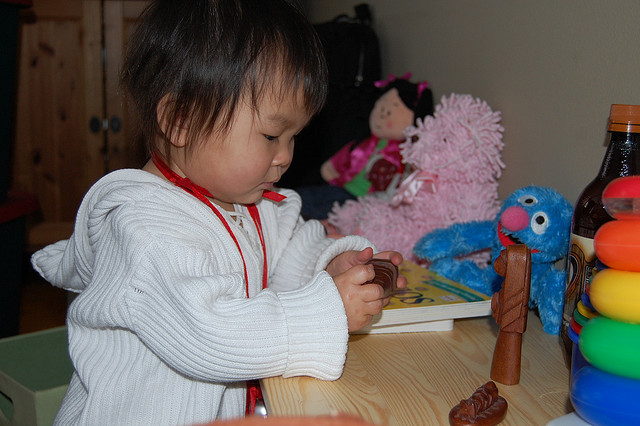<image>Why are there handles on these toys? It is ambiguous why there are handles on these toys. It could be for the baby to hold or for safety. What are the names of the stuffed animals in the high chair? I don't know the names of the stuffed animals in the high chair. They could be Elmo, Cookie Monster, Bob James, Kate, or Grover. What song was being sung while this picture was taken? It's impossible to know what song was being sung while this picture was taken. Why are there handles on these toys? There are handles on these toys for easy gripping and holding. What are the names of the stuffed animals in the high chair? I don't know the names of the stuffed animals in the high chair. What song was being sung while this picture was taken? I don't know what song was being sung while this picture was taken. It can be 'happy birthday', 'b c's', 'if your happy', 'lullaby', 'row your boat', 'old macdonald' or no song at all. 